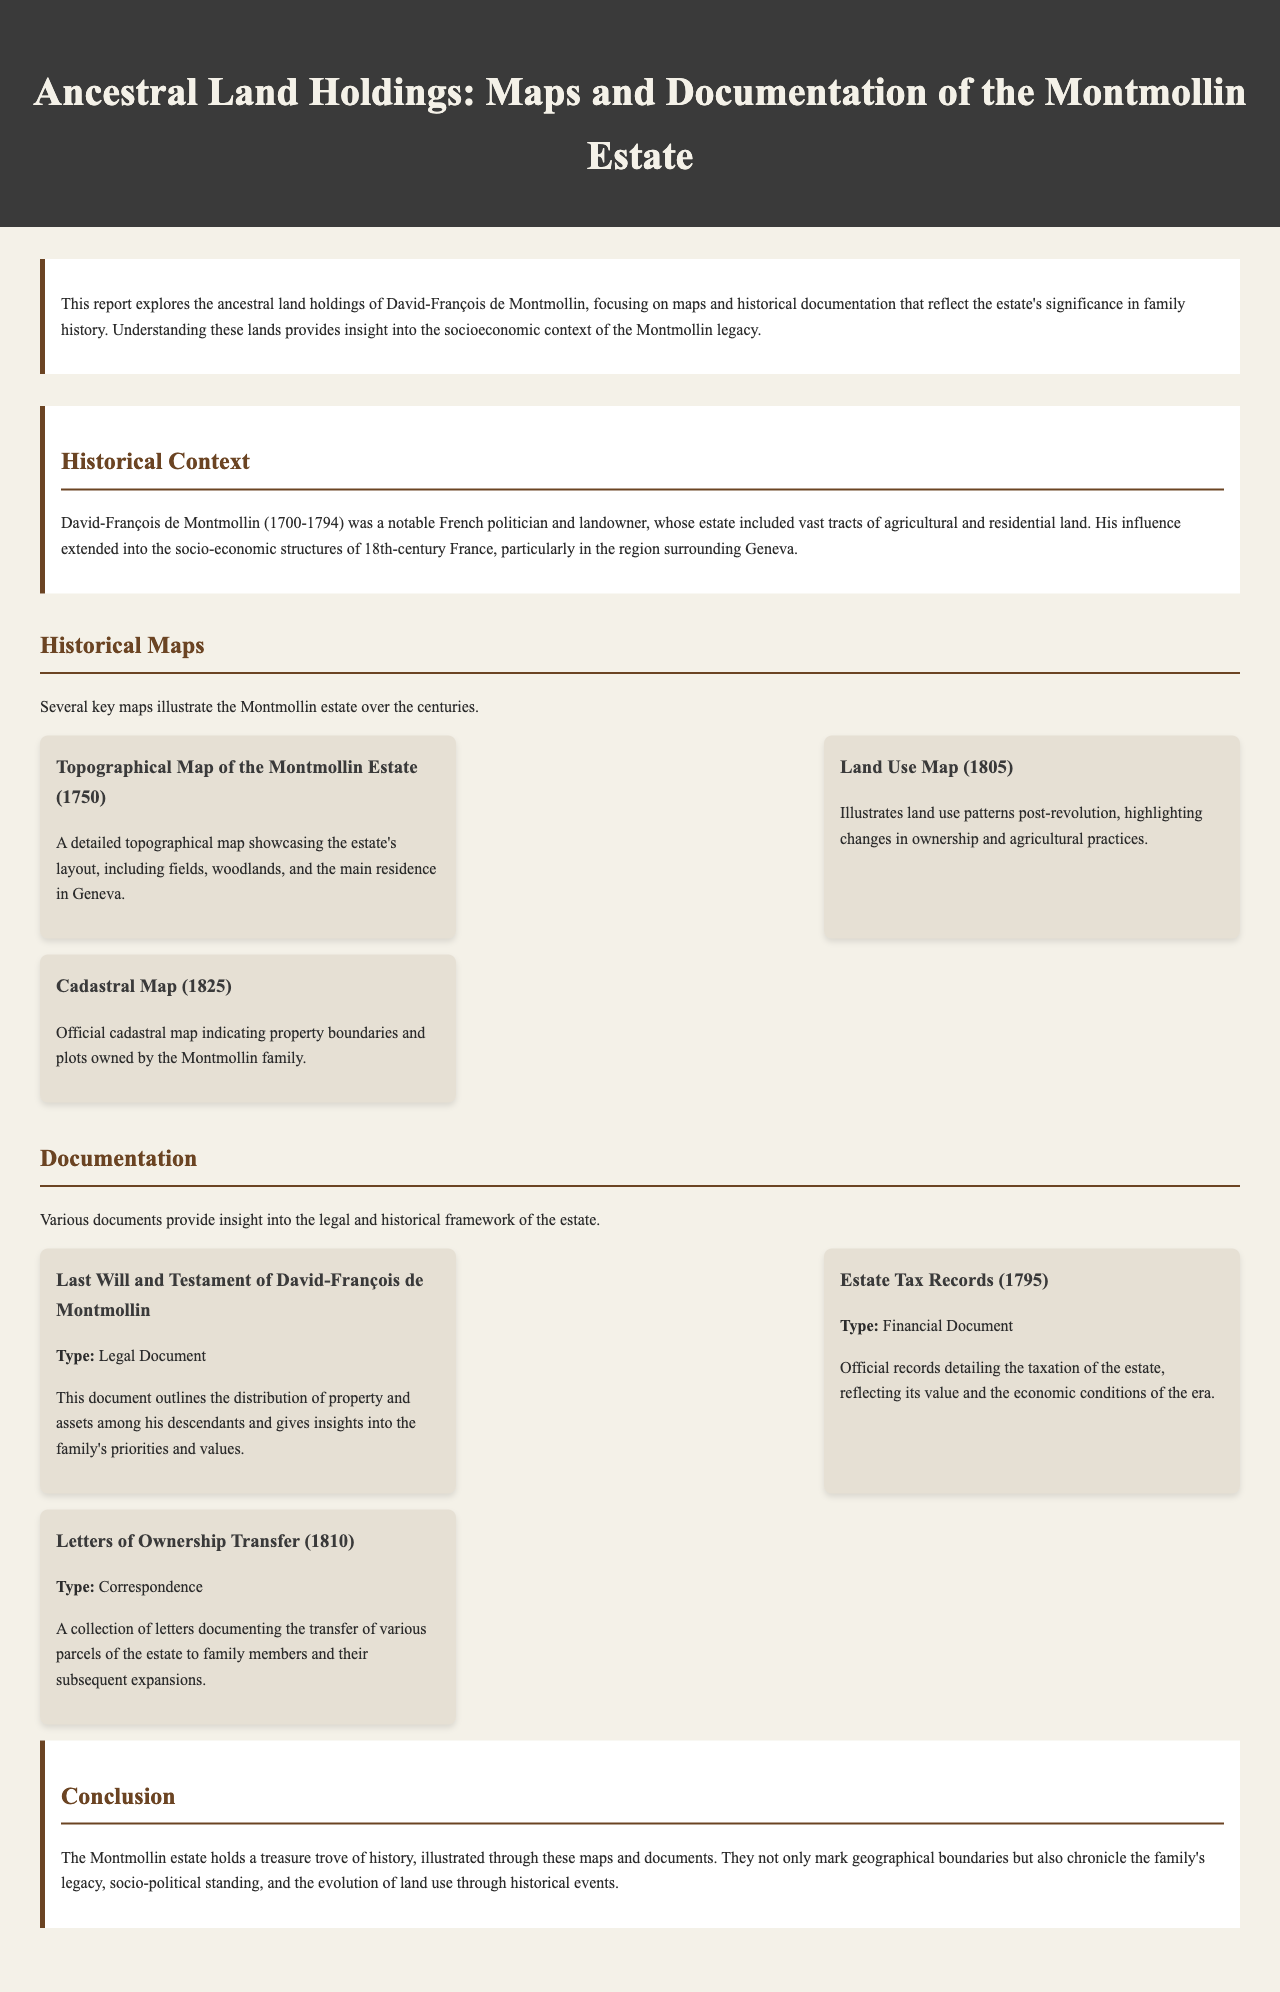what year was the topographical map created? The document states that the topographical map of the Montmollin estate was created in 1750.
Answer: 1750 who was David-François de Montmollin? The document describes David-François de Montmollin as a notable French politician and landowner.
Answer: French politician and landowner what does the land use map illustrate? The land use map illustrates land use patterns post-revolution, highlighting changes in ownership and agricultural practices.
Answer: Land use patterns post-revolution what type of document is the estate tax record? The estate tax record is categorized as a Financial Document in the report.
Answer: Financial Document how many historical maps are mentioned in the document? The document details three historical maps of the Montmollin estate.
Answer: Three what significant event is referenced in the historical context? The document refers to the socio-economic changes following the revolution as a significant event.
Answer: Revolution what type of correspondence is documented in the letters of ownership transfer? The letters of ownership transfer document the transfer of various parcels of the estate to family members.
Answer: Ownership transfer what is the primary focus of this report? The primary focus of the report is the ancestral land holdings of David-François de Montmollin.
Answer: Ancestral land holdings what is indicated by the cadastral map? The cadastral map indicates property boundaries and plots owned by the Montmollin family.
Answer: Property boundaries and plots owned by the Montmollin family 